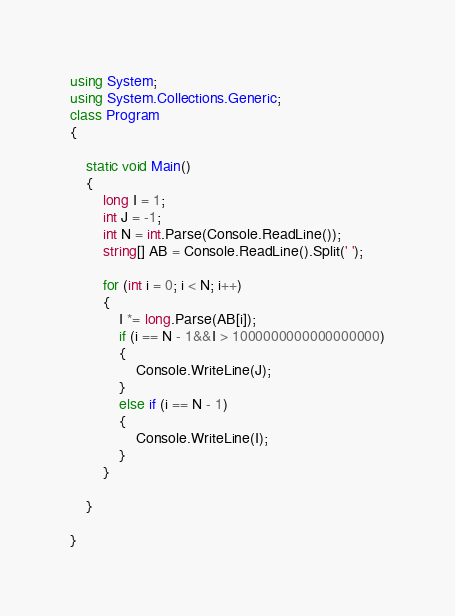<code> <loc_0><loc_0><loc_500><loc_500><_C#_>using System;
using System.Collections.Generic;
class Program
{

    static void Main()
    {
        long I = 1;
        int J = -1;
        int N = int.Parse(Console.ReadLine());
        string[] AB = Console.ReadLine().Split(' ');

        for (int i = 0; i < N; i++)
        {
            I *= long.Parse(AB[i]);
            if (i == N - 1&&I > 1000000000000000000)
            {
                Console.WriteLine(J);
            }
            else if (i == N - 1)
            {
                Console.WriteLine(I);
            }
        }

    }

}</code> 